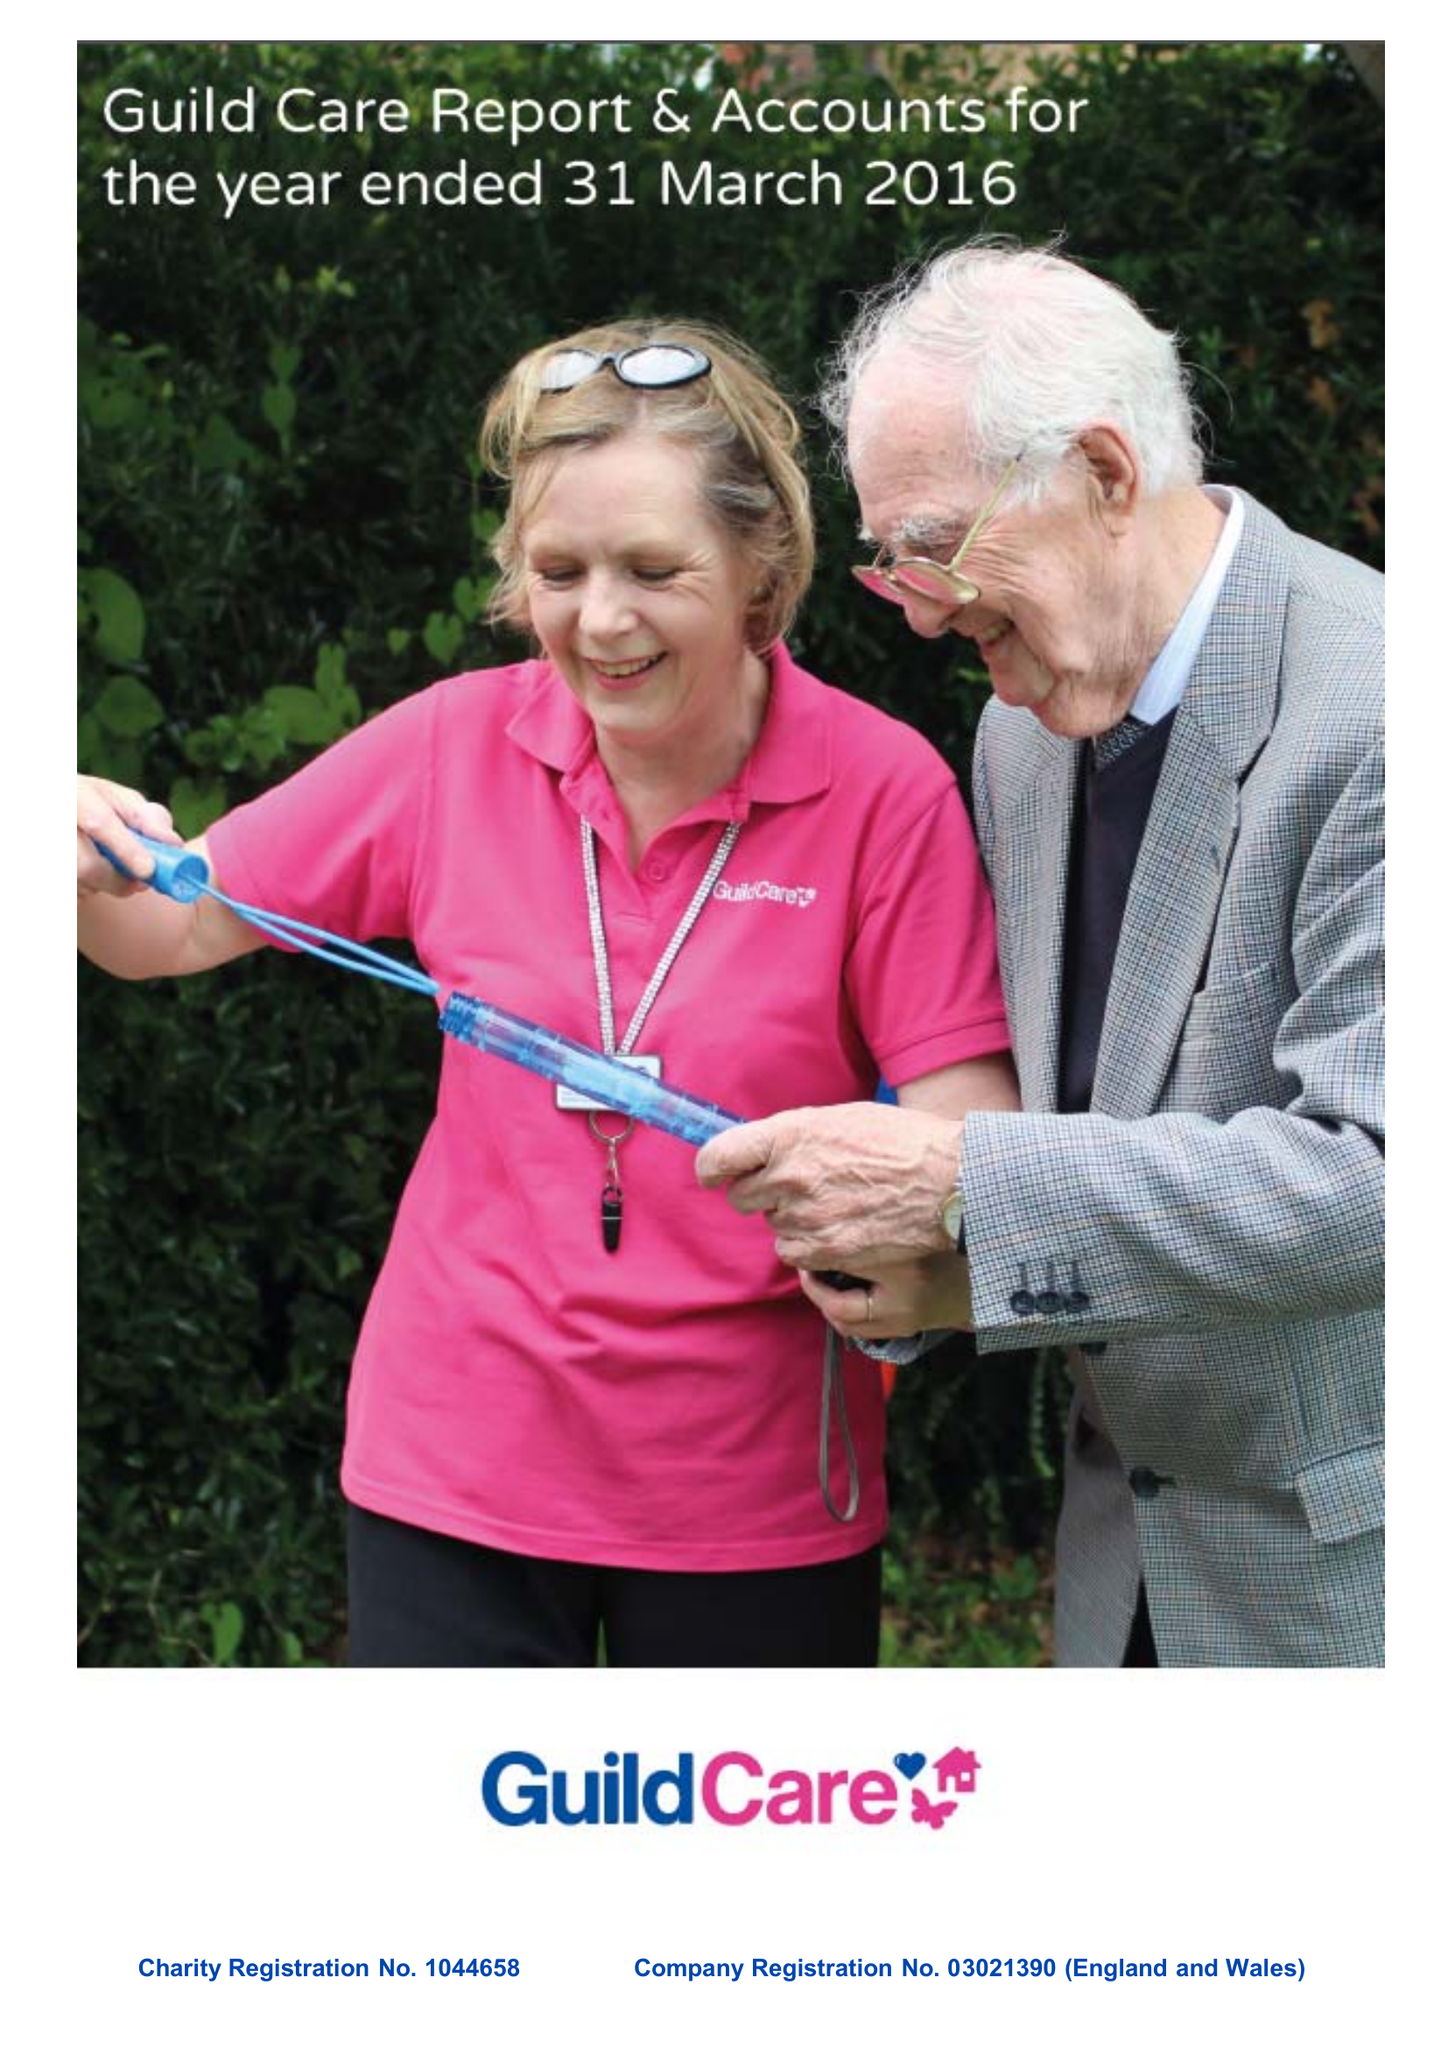What is the value for the charity_number?
Answer the question using a single word or phrase. 1044658 